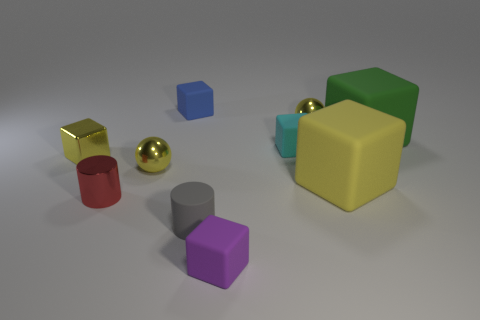Subtract all purple cubes. How many cubes are left? 5 Subtract all small yellow shiny blocks. How many blocks are left? 5 Subtract all red blocks. Subtract all blue balls. How many blocks are left? 6 Subtract all spheres. How many objects are left? 8 Add 1 red cylinders. How many red cylinders are left? 2 Add 3 metallic cubes. How many metallic cubes exist? 4 Subtract 0 cyan spheres. How many objects are left? 10 Subtract all green matte blocks. Subtract all yellow matte things. How many objects are left? 8 